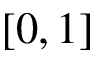Convert formula to latex. <formula><loc_0><loc_0><loc_500><loc_500>[ 0 , 1 ]</formula> 